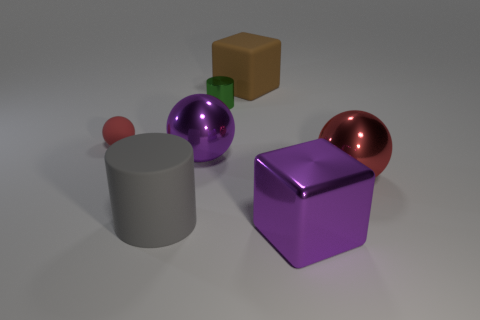Subtract all cyan cubes. How many red balls are left? 2 Subtract all matte balls. How many balls are left? 2 Add 2 small gray shiny cylinders. How many objects exist? 9 Subtract all spheres. How many objects are left? 4 Subtract all yellow spheres. Subtract all green blocks. How many spheres are left? 3 Subtract 1 purple spheres. How many objects are left? 6 Subtract all purple shiny blocks. Subtract all big matte objects. How many objects are left? 4 Add 6 big cylinders. How many big cylinders are left? 7 Add 1 tiny red matte things. How many tiny red matte things exist? 2 